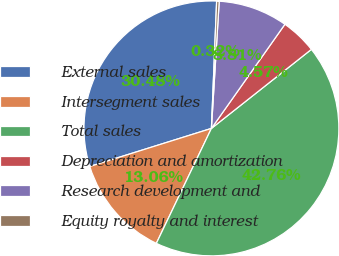Convert chart to OTSL. <chart><loc_0><loc_0><loc_500><loc_500><pie_chart><fcel>External sales<fcel>Intersegment sales<fcel>Total sales<fcel>Depreciation and amortization<fcel>Research development and<fcel>Equity royalty and interest<nl><fcel>30.48%<fcel>13.06%<fcel>42.76%<fcel>4.57%<fcel>8.81%<fcel>0.32%<nl></chart> 